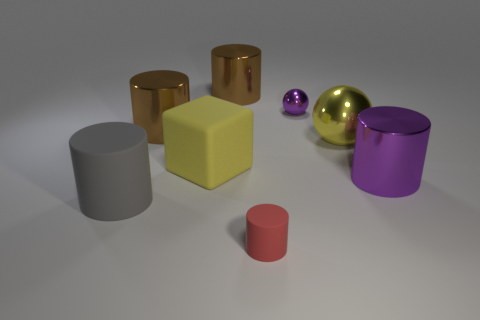Subtract all red cylinders. How many cylinders are left? 4 Subtract all big gray cylinders. How many cylinders are left? 4 Subtract all blue cylinders. Subtract all blue blocks. How many cylinders are left? 5 Add 2 big things. How many objects exist? 10 Subtract all cubes. How many objects are left? 7 Subtract all yellow blocks. Subtract all gray cylinders. How many objects are left? 6 Add 6 purple things. How many purple things are left? 8 Add 2 small red rubber objects. How many small red rubber objects exist? 3 Subtract 1 purple balls. How many objects are left? 7 